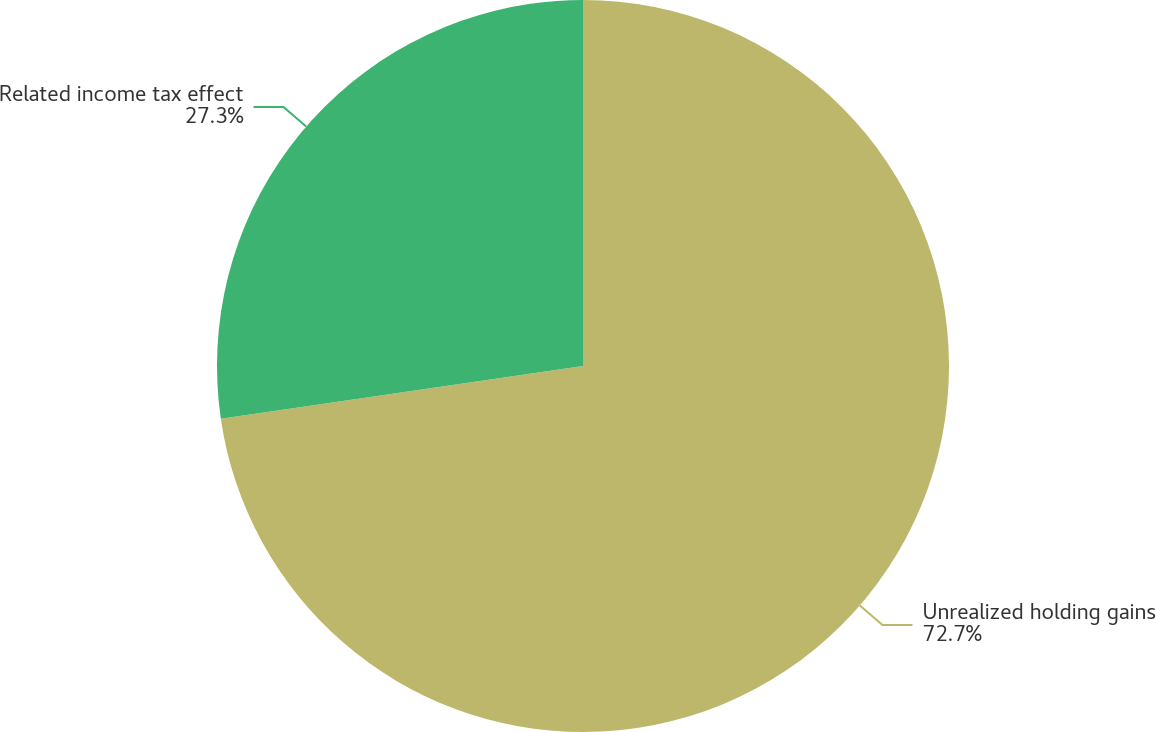Convert chart. <chart><loc_0><loc_0><loc_500><loc_500><pie_chart><fcel>Unrealized holding gains<fcel>Related income tax effect<nl><fcel>72.7%<fcel>27.3%<nl></chart> 